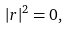Convert formula to latex. <formula><loc_0><loc_0><loc_500><loc_500>| r | ^ { 2 } = 0 ,</formula> 